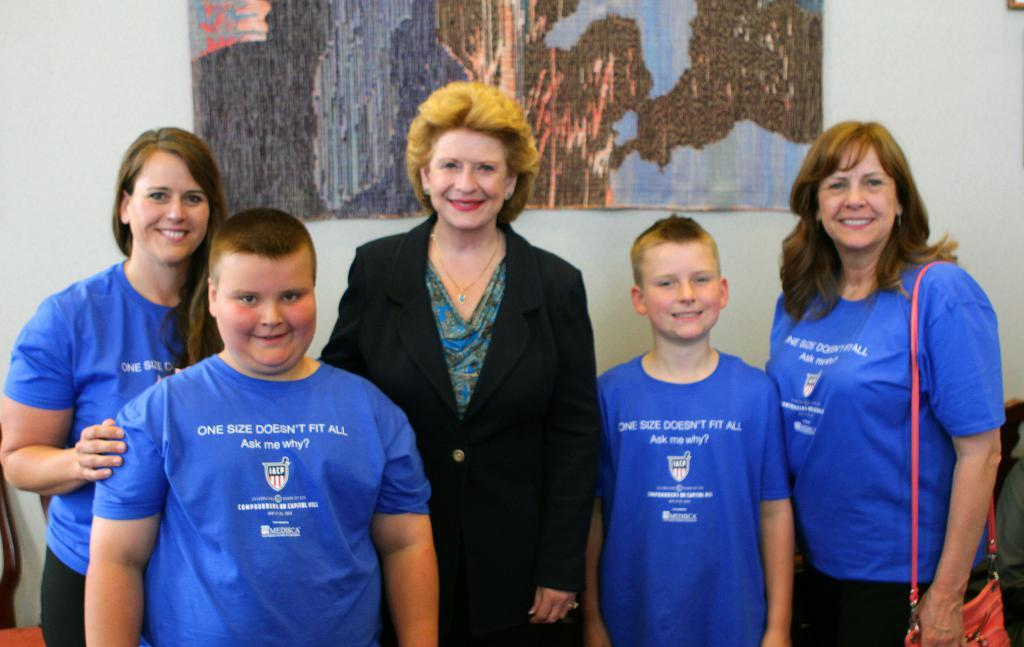<image>
Render a clear and concise summary of the photo. Woman posing with boy wearing blue shirt which says "one size doesn't fit all". 